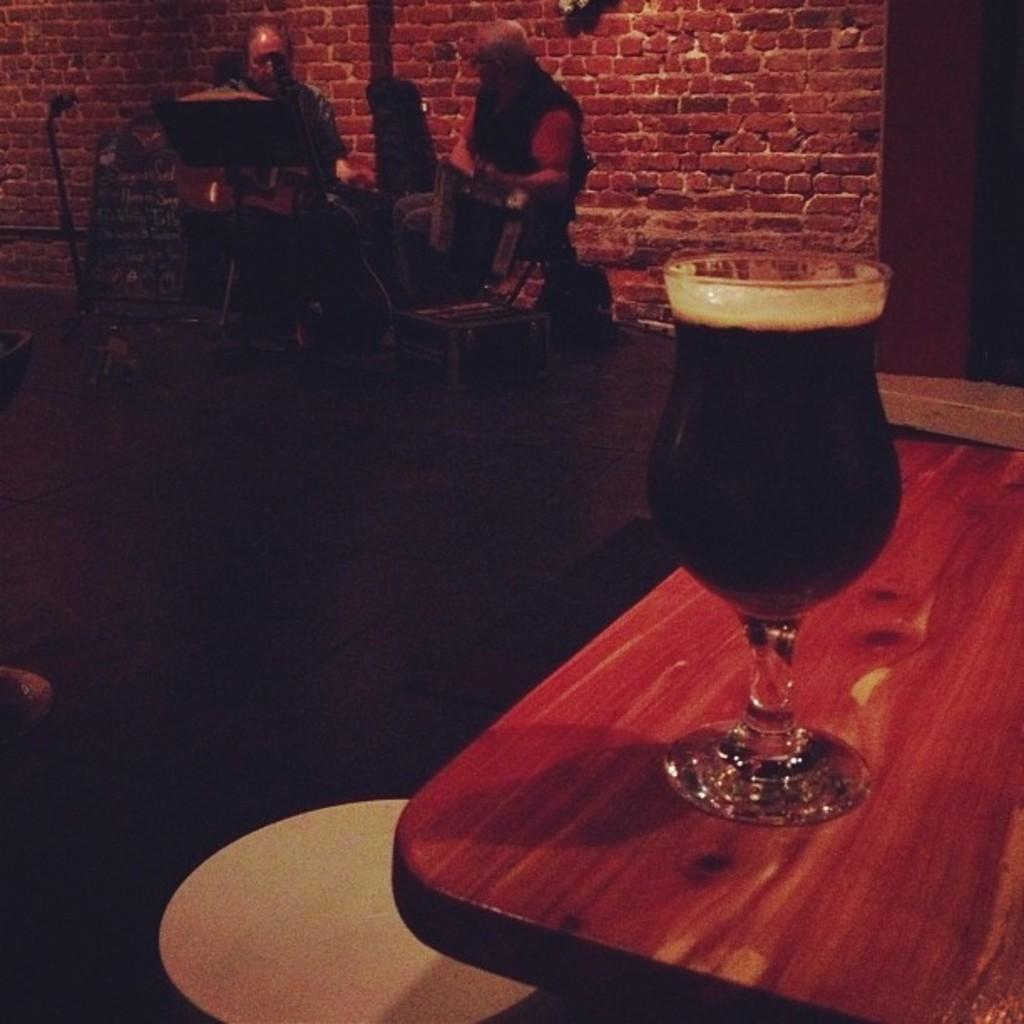How would you summarize this image in a sentence or two? In this picture we can see table and on table we have glass with drink in it and in background we can see two men sitting, wall and it is dark. 